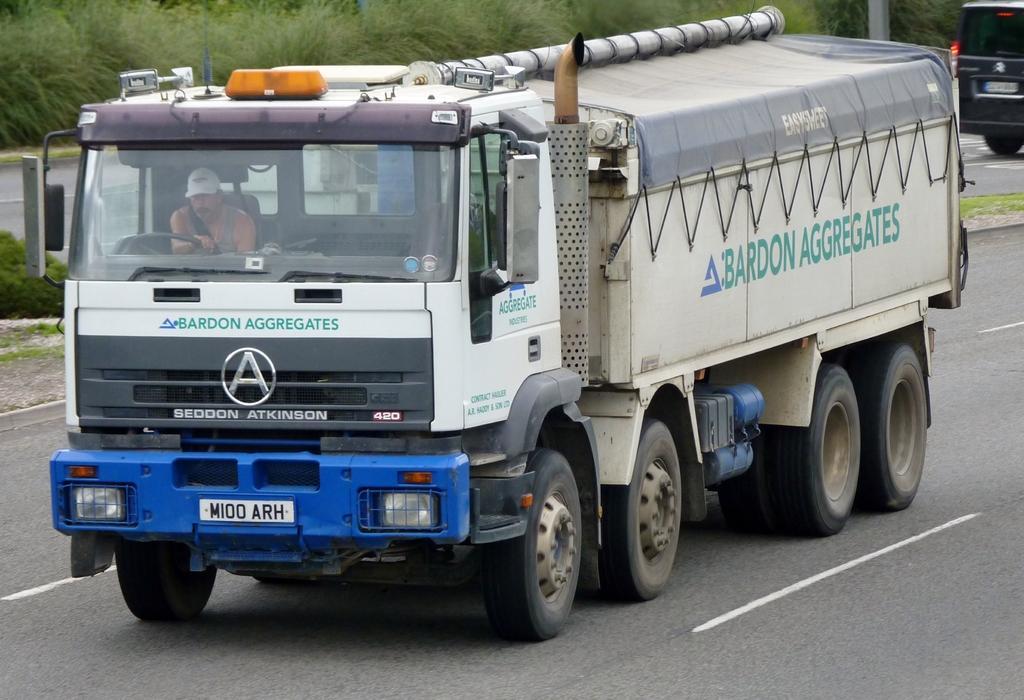Describe this image in one or two sentences. There is a vehicle on the road and there is greenery grass in the background. 